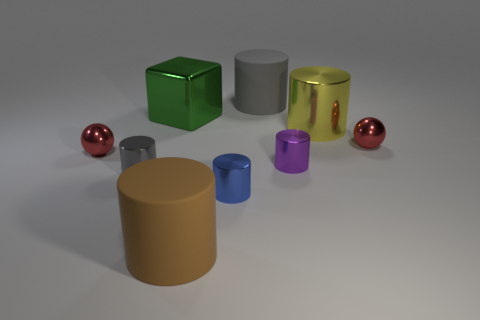Subtract 4 cylinders. How many cylinders are left? 2 Subtract all large shiny cylinders. How many cylinders are left? 5 Subtract all gray cylinders. How many cylinders are left? 4 Subtract all red cylinders. Subtract all yellow spheres. How many cylinders are left? 6 Subtract all cubes. How many objects are left? 8 Add 1 small gray metallic cylinders. How many small gray metallic cylinders are left? 2 Add 4 tiny red spheres. How many tiny red spheres exist? 6 Subtract 0 purple blocks. How many objects are left? 9 Subtract all gray metal cubes. Subtract all large yellow objects. How many objects are left? 8 